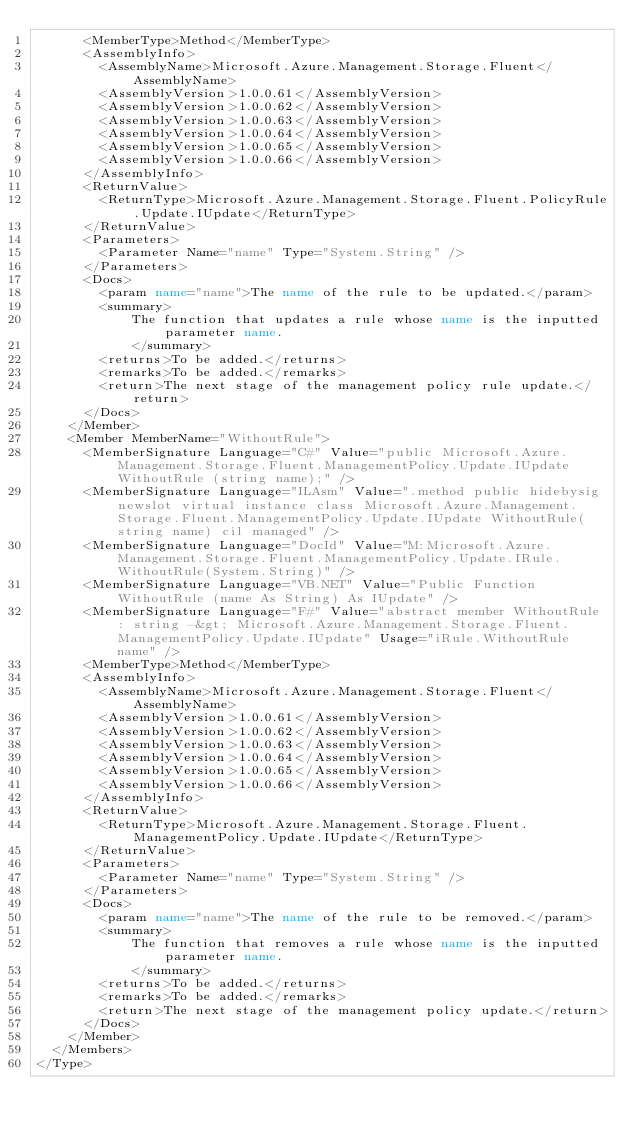Convert code to text. <code><loc_0><loc_0><loc_500><loc_500><_XML_>      <MemberType>Method</MemberType>
      <AssemblyInfo>
        <AssemblyName>Microsoft.Azure.Management.Storage.Fluent</AssemblyName>
        <AssemblyVersion>1.0.0.61</AssemblyVersion>
        <AssemblyVersion>1.0.0.62</AssemblyVersion>
        <AssemblyVersion>1.0.0.63</AssemblyVersion>
        <AssemblyVersion>1.0.0.64</AssemblyVersion>
        <AssemblyVersion>1.0.0.65</AssemblyVersion>
        <AssemblyVersion>1.0.0.66</AssemblyVersion>
      </AssemblyInfo>
      <ReturnValue>
        <ReturnType>Microsoft.Azure.Management.Storage.Fluent.PolicyRule.Update.IUpdate</ReturnType>
      </ReturnValue>
      <Parameters>
        <Parameter Name="name" Type="System.String" />
      </Parameters>
      <Docs>
        <param name="name">The name of the rule to be updated.</param>
        <summary>
            The function that updates a rule whose name is the inputted parameter name.
            </summary>
        <returns>To be added.</returns>
        <remarks>To be added.</remarks>
        <return>The next stage of the management policy rule update.</return>
      </Docs>
    </Member>
    <Member MemberName="WithoutRule">
      <MemberSignature Language="C#" Value="public Microsoft.Azure.Management.Storage.Fluent.ManagementPolicy.Update.IUpdate WithoutRule (string name);" />
      <MemberSignature Language="ILAsm" Value=".method public hidebysig newslot virtual instance class Microsoft.Azure.Management.Storage.Fluent.ManagementPolicy.Update.IUpdate WithoutRule(string name) cil managed" />
      <MemberSignature Language="DocId" Value="M:Microsoft.Azure.Management.Storage.Fluent.ManagementPolicy.Update.IRule.WithoutRule(System.String)" />
      <MemberSignature Language="VB.NET" Value="Public Function WithoutRule (name As String) As IUpdate" />
      <MemberSignature Language="F#" Value="abstract member WithoutRule : string -&gt; Microsoft.Azure.Management.Storage.Fluent.ManagementPolicy.Update.IUpdate" Usage="iRule.WithoutRule name" />
      <MemberType>Method</MemberType>
      <AssemblyInfo>
        <AssemblyName>Microsoft.Azure.Management.Storage.Fluent</AssemblyName>
        <AssemblyVersion>1.0.0.61</AssemblyVersion>
        <AssemblyVersion>1.0.0.62</AssemblyVersion>
        <AssemblyVersion>1.0.0.63</AssemblyVersion>
        <AssemblyVersion>1.0.0.64</AssemblyVersion>
        <AssemblyVersion>1.0.0.65</AssemblyVersion>
        <AssemblyVersion>1.0.0.66</AssemblyVersion>
      </AssemblyInfo>
      <ReturnValue>
        <ReturnType>Microsoft.Azure.Management.Storage.Fluent.ManagementPolicy.Update.IUpdate</ReturnType>
      </ReturnValue>
      <Parameters>
        <Parameter Name="name" Type="System.String" />
      </Parameters>
      <Docs>
        <param name="name">The name of the rule to be removed.</param>
        <summary>
            The function that removes a rule whose name is the inputted parameter name.
            </summary>
        <returns>To be added.</returns>
        <remarks>To be added.</remarks>
        <return>The next stage of the management policy update.</return>
      </Docs>
    </Member>
  </Members>
</Type>
</code> 